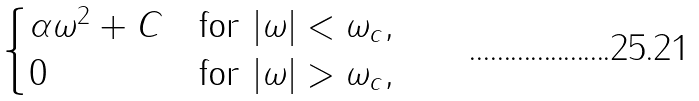<formula> <loc_0><loc_0><loc_500><loc_500>\begin{cases} \alpha \omega ^ { 2 } + C & \text {for $|\omega| < \omega_{c}$} , \\ 0 & \text {for $|\omega| > \omega_{c}$} , \end{cases}</formula> 